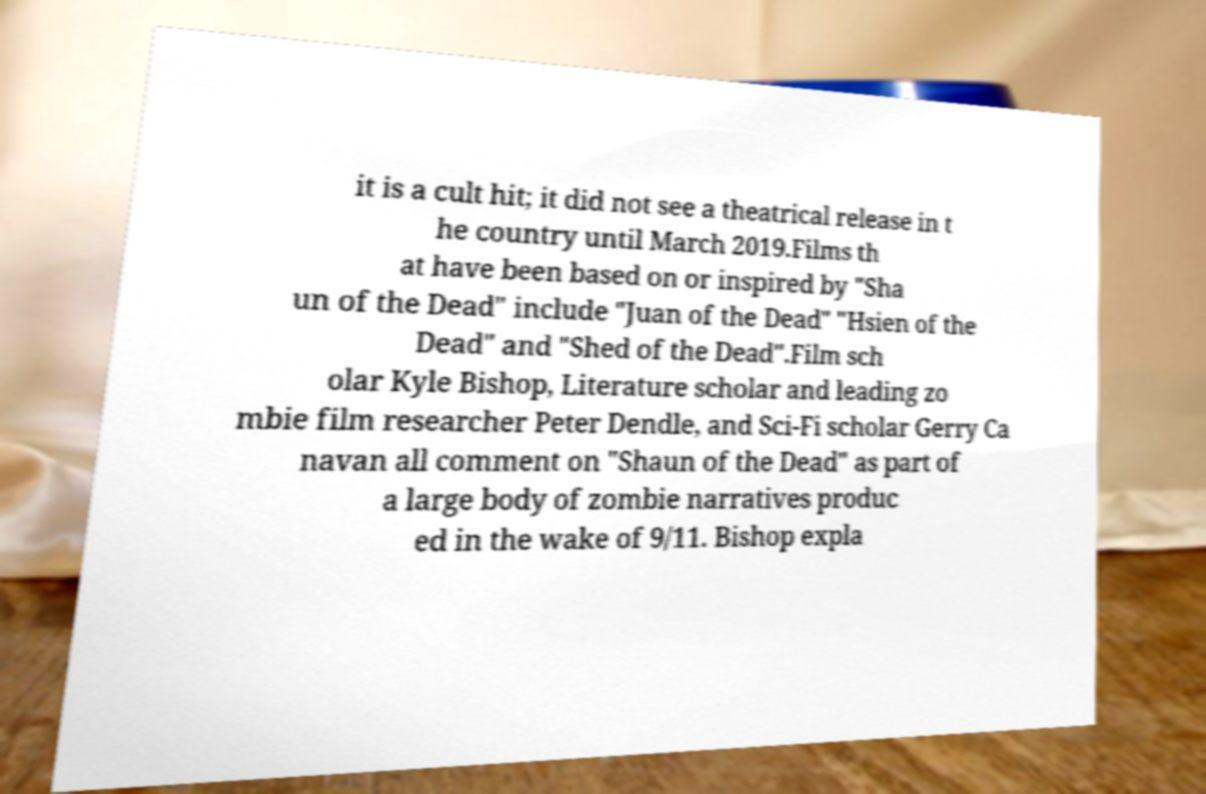Could you extract and type out the text from this image? it is a cult hit; it did not see a theatrical release in t he country until March 2019.Films th at have been based on or inspired by "Sha un of the Dead" include "Juan of the Dead" "Hsien of the Dead" and "Shed of the Dead".Film sch olar Kyle Bishop, Literature scholar and leading zo mbie film researcher Peter Dendle, and Sci-Fi scholar Gerry Ca navan all comment on "Shaun of the Dead" as part of a large body of zombie narratives produc ed in the wake of 9/11. Bishop expla 